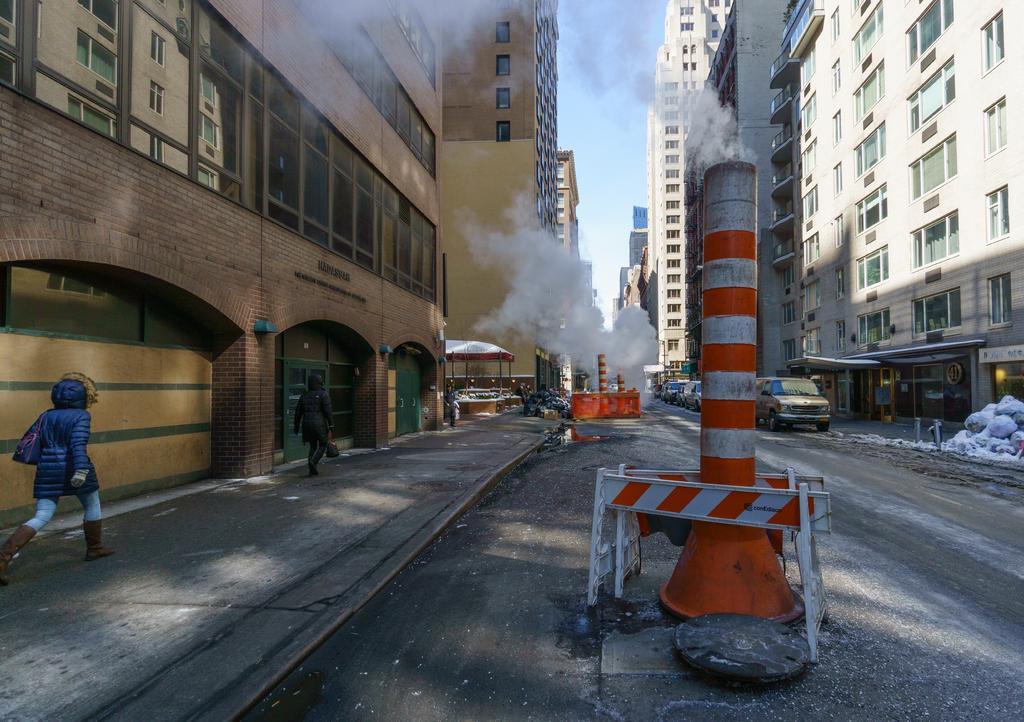In one or two sentences, can you explain what this image depicts? In this image I can see few buildings and glass windows. I can see few people are walking and holding bags. I can see a white and orange color poles,smoke and few vehicles on the road. The sky is in blue and white color. 